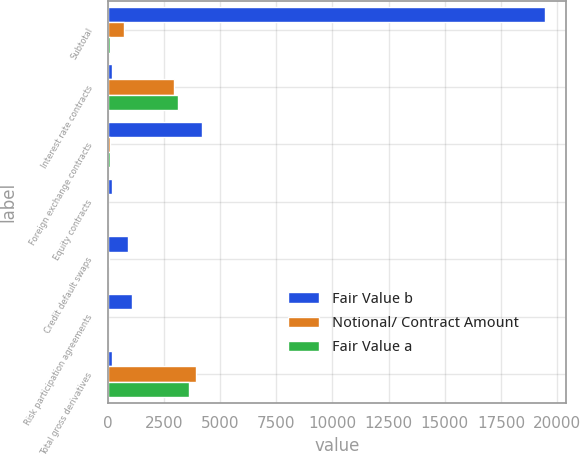<chart> <loc_0><loc_0><loc_500><loc_500><stacked_bar_chart><ecel><fcel>Subtotal<fcel>Interest rate contracts<fcel>Foreign exchange contracts<fcel>Equity contracts<fcel>Credit default swaps<fcel>Risk participation agreements<fcel>Total gross derivatives<nl><fcel>Fair Value b<fcel>19442<fcel>195<fcel>4208<fcel>195<fcel>926<fcel>1091<fcel>195<nl><fcel>Notional/ Contract Amount<fcel>739<fcel>2963<fcel>123<fcel>16<fcel>72<fcel>3<fcel>3916<nl><fcel>Fair Value a<fcel>95<fcel>3110<fcel>108<fcel>16<fcel>22<fcel>2<fcel>3628<nl></chart> 